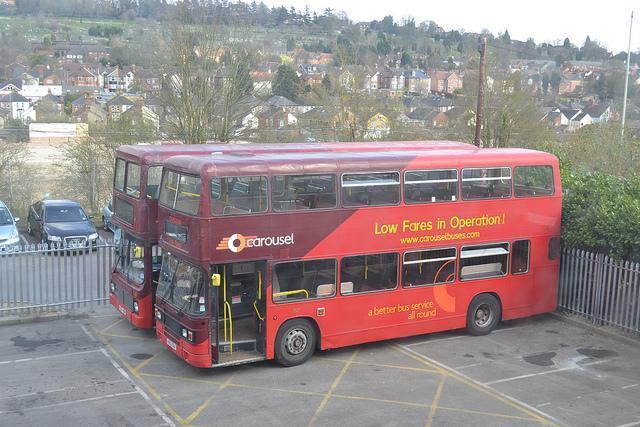How many buses are in the picture?
Give a very brief answer. 2. How many cars are visible?
Give a very brief answer. 1. How many dogs are on he bench in this image?
Give a very brief answer. 0. 